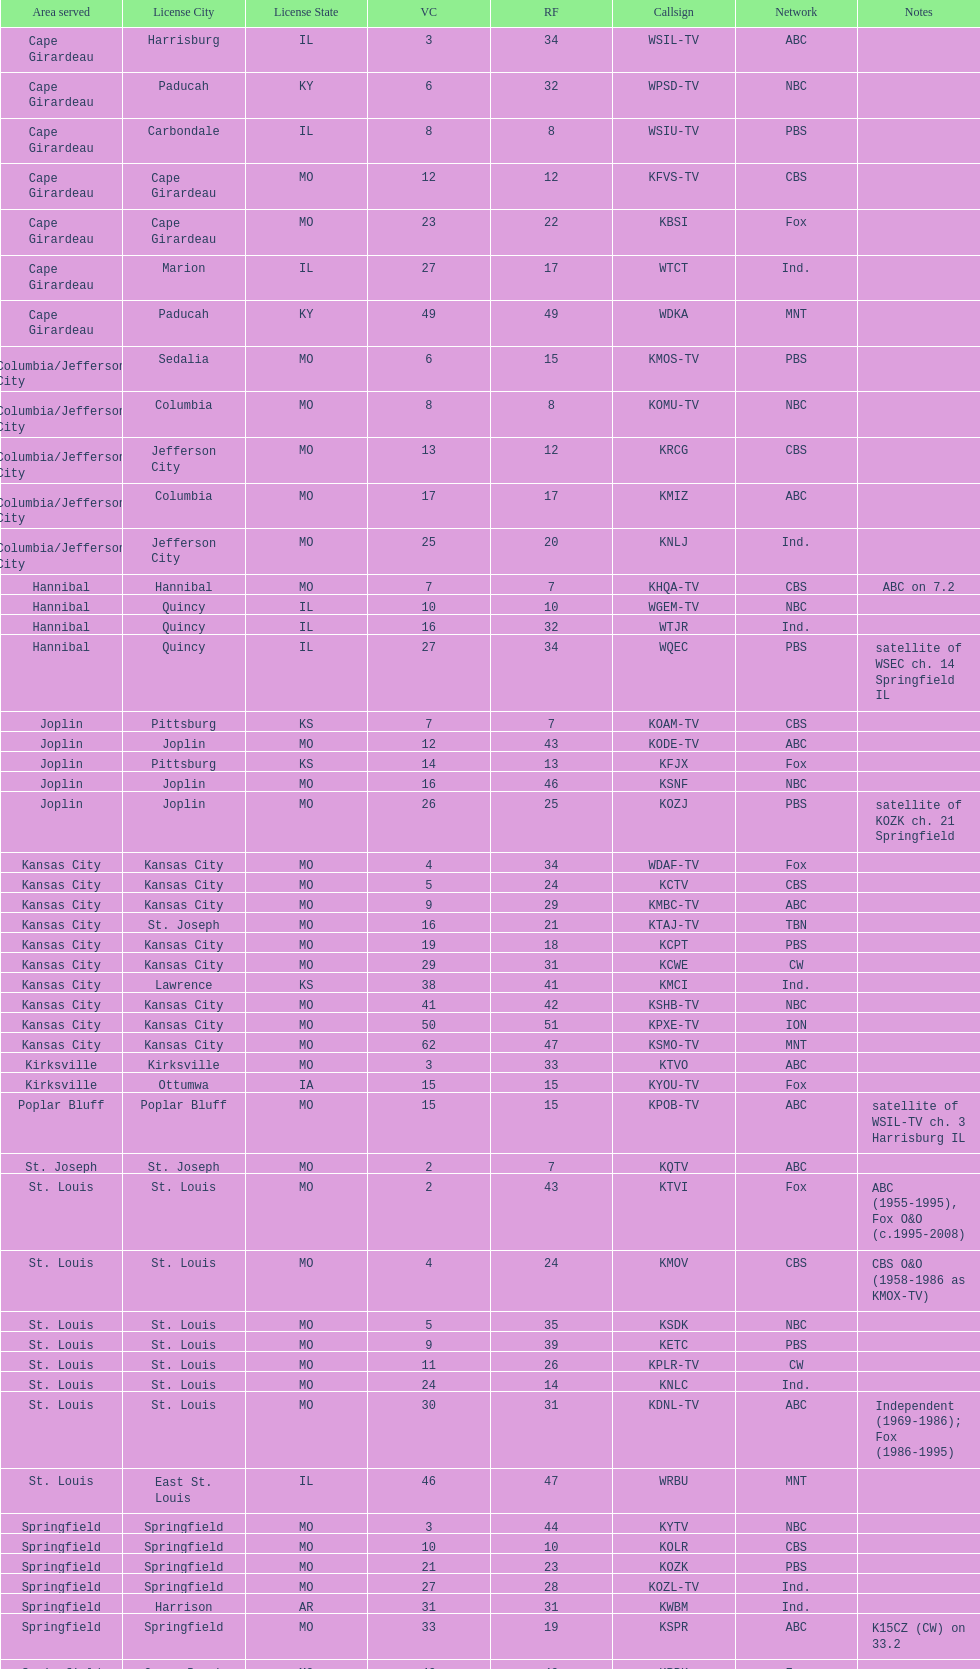How many of these missouri tv stations are actually licensed in a city in illinois (il)? 7. 